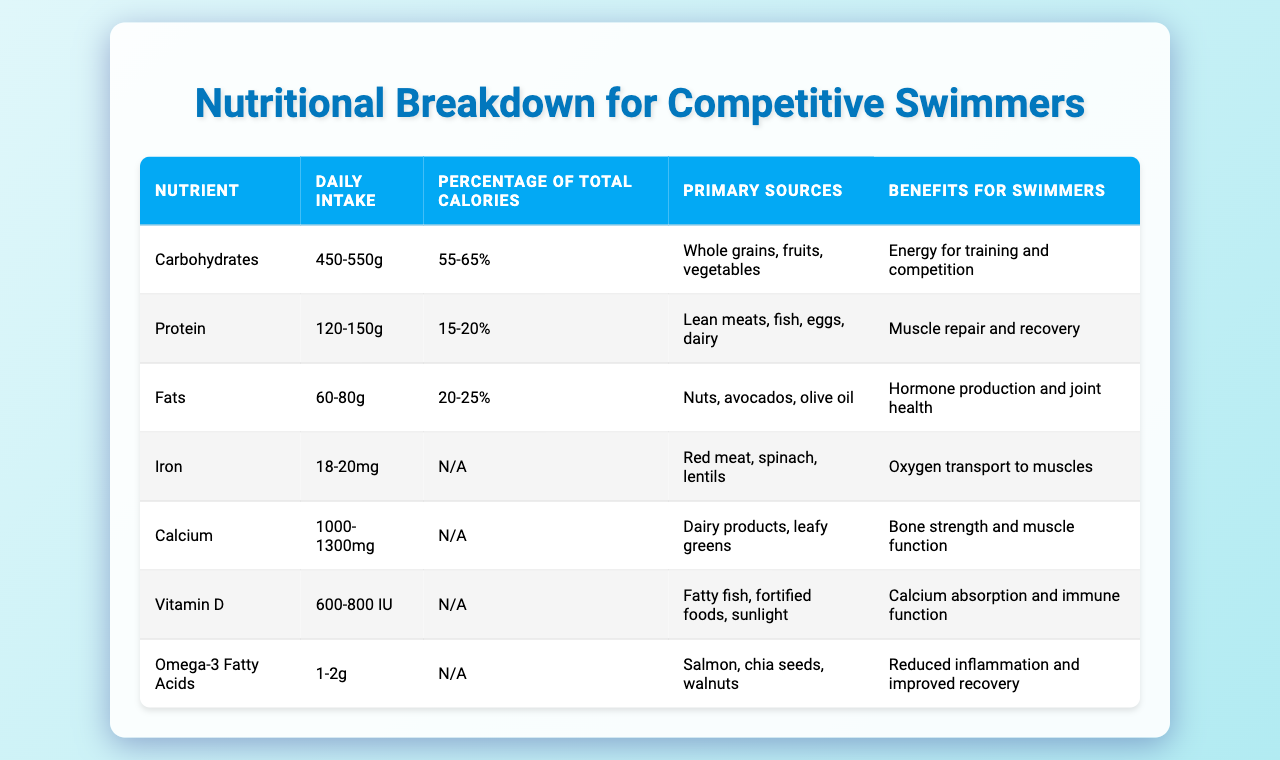What is the daily intake range for carbohydrates? The table indicates that the daily intake for carbohydrates ranges from 450 to 550 grams.
Answer: 450-550g What percentage of total calories do fats contribute to a swimmer’s diet? According to the table, fats contribute to 20-25% of total calories.
Answer: 20-25% Which nutrient has the primary source of nuts? The table shows that fats have nuts as one of their primary sources.
Answer: Fats Is the daily intake for calcium defined in terms of total calories? The table specifies that the intake for calcium is given as a range without being related to total calories (N/A).
Answer: No What is the primary benefit of omega-3 fatty acids for swimmers? The table states that omega-3 fatty acids help reduce inflammation and improve recovery, which is beneficial for swimmers.
Answer: Reduced inflammation and improved recovery If a swimmer consumes the maximum recommended daily intake of protein at 150g, how much of their calories would that approximately represent? Protein is 15-20% of total calories; if we assume a diet of 3000 calories, then 150g of protein would be approximately 20% of total calories (150g x 4 kcal/g = 600 kcal, and 600 kcal/3000 kcal = 20%).
Answer: Approximately 20% Which nutrient contributes the most to the energy required for training and competitions? The table shows that carbohydrates are the primary source of energy for training and competition, as they have the highest daily intake and percentage of calories.
Answer: Carbohydrates What is the combined daily intake for iron and calcium based on the given ranges? The daily intake for iron is 18-20mg and for calcium is 1000-1300mg. If we calculate the combined maximum, it would be 20mg (iron) + 1300mg (calcium) = 1320mg; the combined minimum would be 18mg (iron) + 1000mg (calcium) = 1018mg.
Answer: 1018-1320mg How do the primary sources of protein and carbohydrates differ? The table indicates that protein sources are lean meats, fish, eggs, and dairy, while carbohydrates come primarily from whole grains, fruits, and vegetables, thus showing a diversity in food types and nutrients.
Answer: They differ significantly If a swimmer adheres strictly to the daily intake recommendations, what is the potential range of total calorie intake from carbohydrates alone? Carbohydrates provide 4 kcal per gram. Therefore, for a minimum of 450g, the calories would be 450g x 4 = 1800 kcal and for a maximum of 550g, it would be 550g x 4 = 2200 kcal. Hence, the calorie range from carbohydrates would be 1800-2200 kcal.
Answer: 1800-2200 kcal 